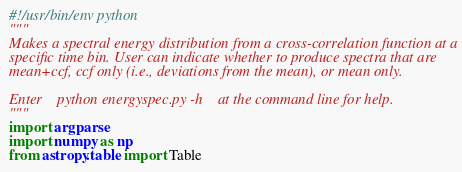<code> <loc_0><loc_0><loc_500><loc_500><_Python_>#!/usr/bin/env python
"""
Makes a spectral energy distribution from a cross-correlation function at a
specific time bin. User can indicate whether to produce spectra that are
mean+ccf, ccf only (i.e., deviations from the mean), or mean only.

Enter    python energyspec.py -h    at the command line for help.
"""
import argparse
import numpy as np
from astropy.table import Table</code> 